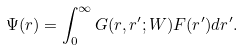<formula> <loc_0><loc_0><loc_500><loc_500>\Psi ( r ) = \int _ { 0 } ^ { \infty } G ( r , r ^ { \prime } ; W ) F ( r ^ { \prime } ) d r ^ { \prime } .</formula> 